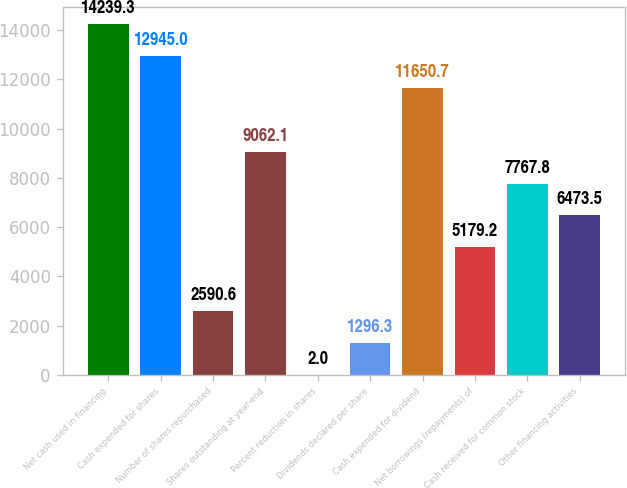Convert chart to OTSL. <chart><loc_0><loc_0><loc_500><loc_500><bar_chart><fcel>Net cash used in financing<fcel>Cash expended for shares<fcel>Number of shares repurchased<fcel>Shares outstanding at year-end<fcel>Percent reduction in shares<fcel>Dividends declared per share<fcel>Cash expended for dividend<fcel>Net borrowings (repayments) of<fcel>Cash received for common stock<fcel>Other financing activities<nl><fcel>14239.3<fcel>12945<fcel>2590.6<fcel>9062.1<fcel>2<fcel>1296.3<fcel>11650.7<fcel>5179.2<fcel>7767.8<fcel>6473.5<nl></chart> 